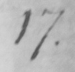Please transcribe the handwritten text in this image. 17 . 